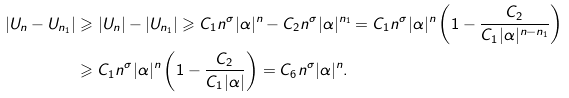Convert formula to latex. <formula><loc_0><loc_0><loc_500><loc_500>| U _ { n } - U _ { n _ { 1 } } | & \geqslant | U _ { n } | - | U _ { n _ { 1 } } | \geqslant C _ { 1 } n ^ { \sigma } | \alpha | ^ { n } - C _ { 2 } n ^ { \sigma } | \alpha | ^ { n _ { 1 } } = C _ { 1 } n ^ { \sigma } | \alpha | ^ { n } \left ( 1 - \frac { C _ { 2 } } { C _ { 1 } | \alpha | ^ { n - n _ { 1 } } } \right ) \\ & \geqslant C _ { 1 } n ^ { \sigma } | \alpha | ^ { n } \left ( 1 - \frac { C _ { 2 } } { C _ { 1 } | \alpha | } \right ) = C _ { 6 } n ^ { \sigma } | \alpha | ^ { n } .</formula> 